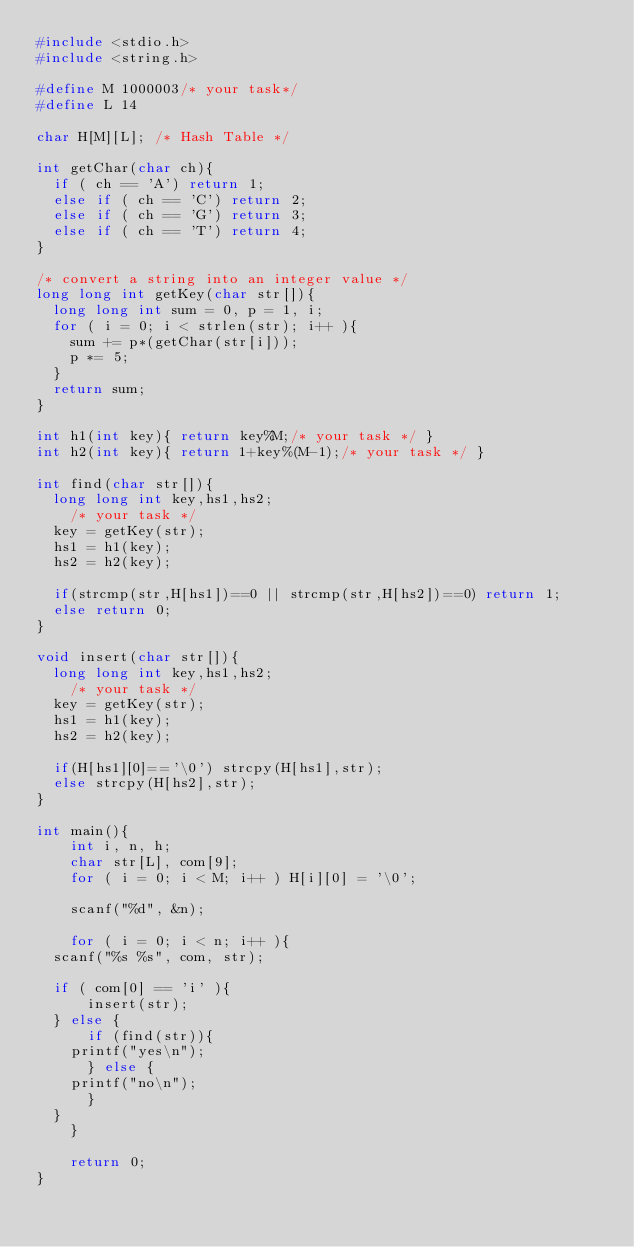<code> <loc_0><loc_0><loc_500><loc_500><_C_>#include <stdio.h>
#include <string.h>

#define M 1000003/* your task*/
#define L 14

char H[M][L]; /* Hash Table */

int getChar(char ch){
  if ( ch == 'A') return 1;
  else if ( ch == 'C') return 2;
  else if ( ch == 'G') return 3;
  else if ( ch == 'T') return 4;
}

/* convert a string into an integer value */
long long int getKey(char str[]){
  long long int sum = 0, p = 1, i;
  for ( i = 0; i < strlen(str); i++ ){
    sum += p*(getChar(str[i]));
    p *= 5;
  }
  return sum;
}

int h1(int key){ return key%M;/* your task */ }
int h2(int key){ return 1+key%(M-1);/* your task */ }

int find(char str[]){
  long long int key,hs1,hs2;
    /* your task */
  key = getKey(str);
  hs1 = h1(key);
  hs2 = h2(key);
  
  if(strcmp(str,H[hs1])==0 || strcmp(str,H[hs2])==0) return 1;
  else return 0;
}

void insert(char str[]){
  long long int key,hs1,hs2;
    /* your task */
  key = getKey(str);
  hs1 = h1(key);
  hs2 = h2(key);

  if(H[hs1][0]=='\0') strcpy(H[hs1],str);
  else strcpy(H[hs2],str); 
}

int main(){
    int i, n, h;
    char str[L], com[9];
    for ( i = 0; i < M; i++ ) H[i][0] = '\0';
    
    scanf("%d", &n);
    
    for ( i = 0; i < n; i++ ){
	scanf("%s %s", com, str);
	
	if ( com[0] == 'i' ){
	    insert(str);
	} else {
	    if (find(str)){
		printf("yes\n");
	    } else {
		printf("no\n");
	    }
	}
    }

    return 0;
}

</code> 